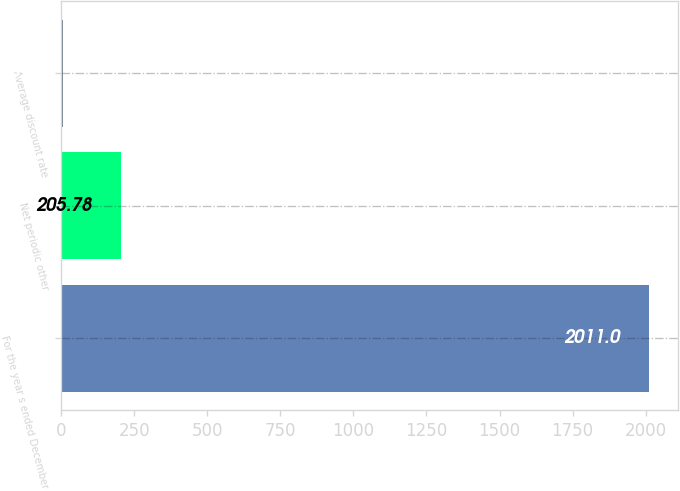Convert chart. <chart><loc_0><loc_0><loc_500><loc_500><bar_chart><fcel>For the year s ended December<fcel>Net periodic other<fcel>Average discount rate<nl><fcel>2011<fcel>205.78<fcel>5.2<nl></chart> 